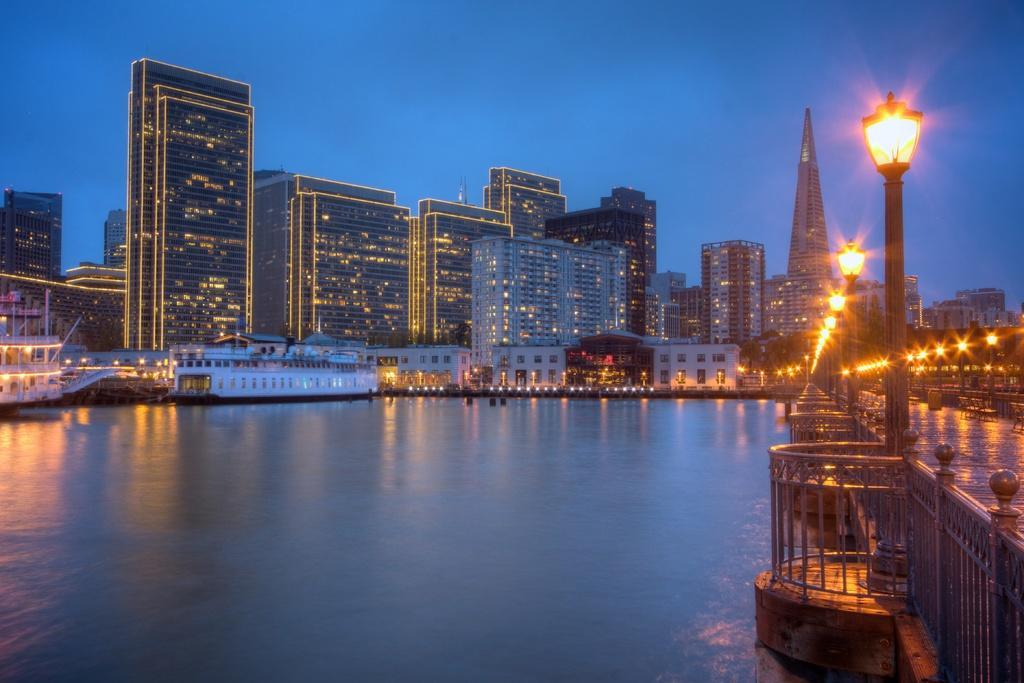Could you give a brief overview of what you see in this image? In this picture we can see the buildings, lights. On the right side of the image we can see a tower, poles, lights, railing, bridge. In the background of the image we can see the boats and water. At the top of the image we can see the sky. 